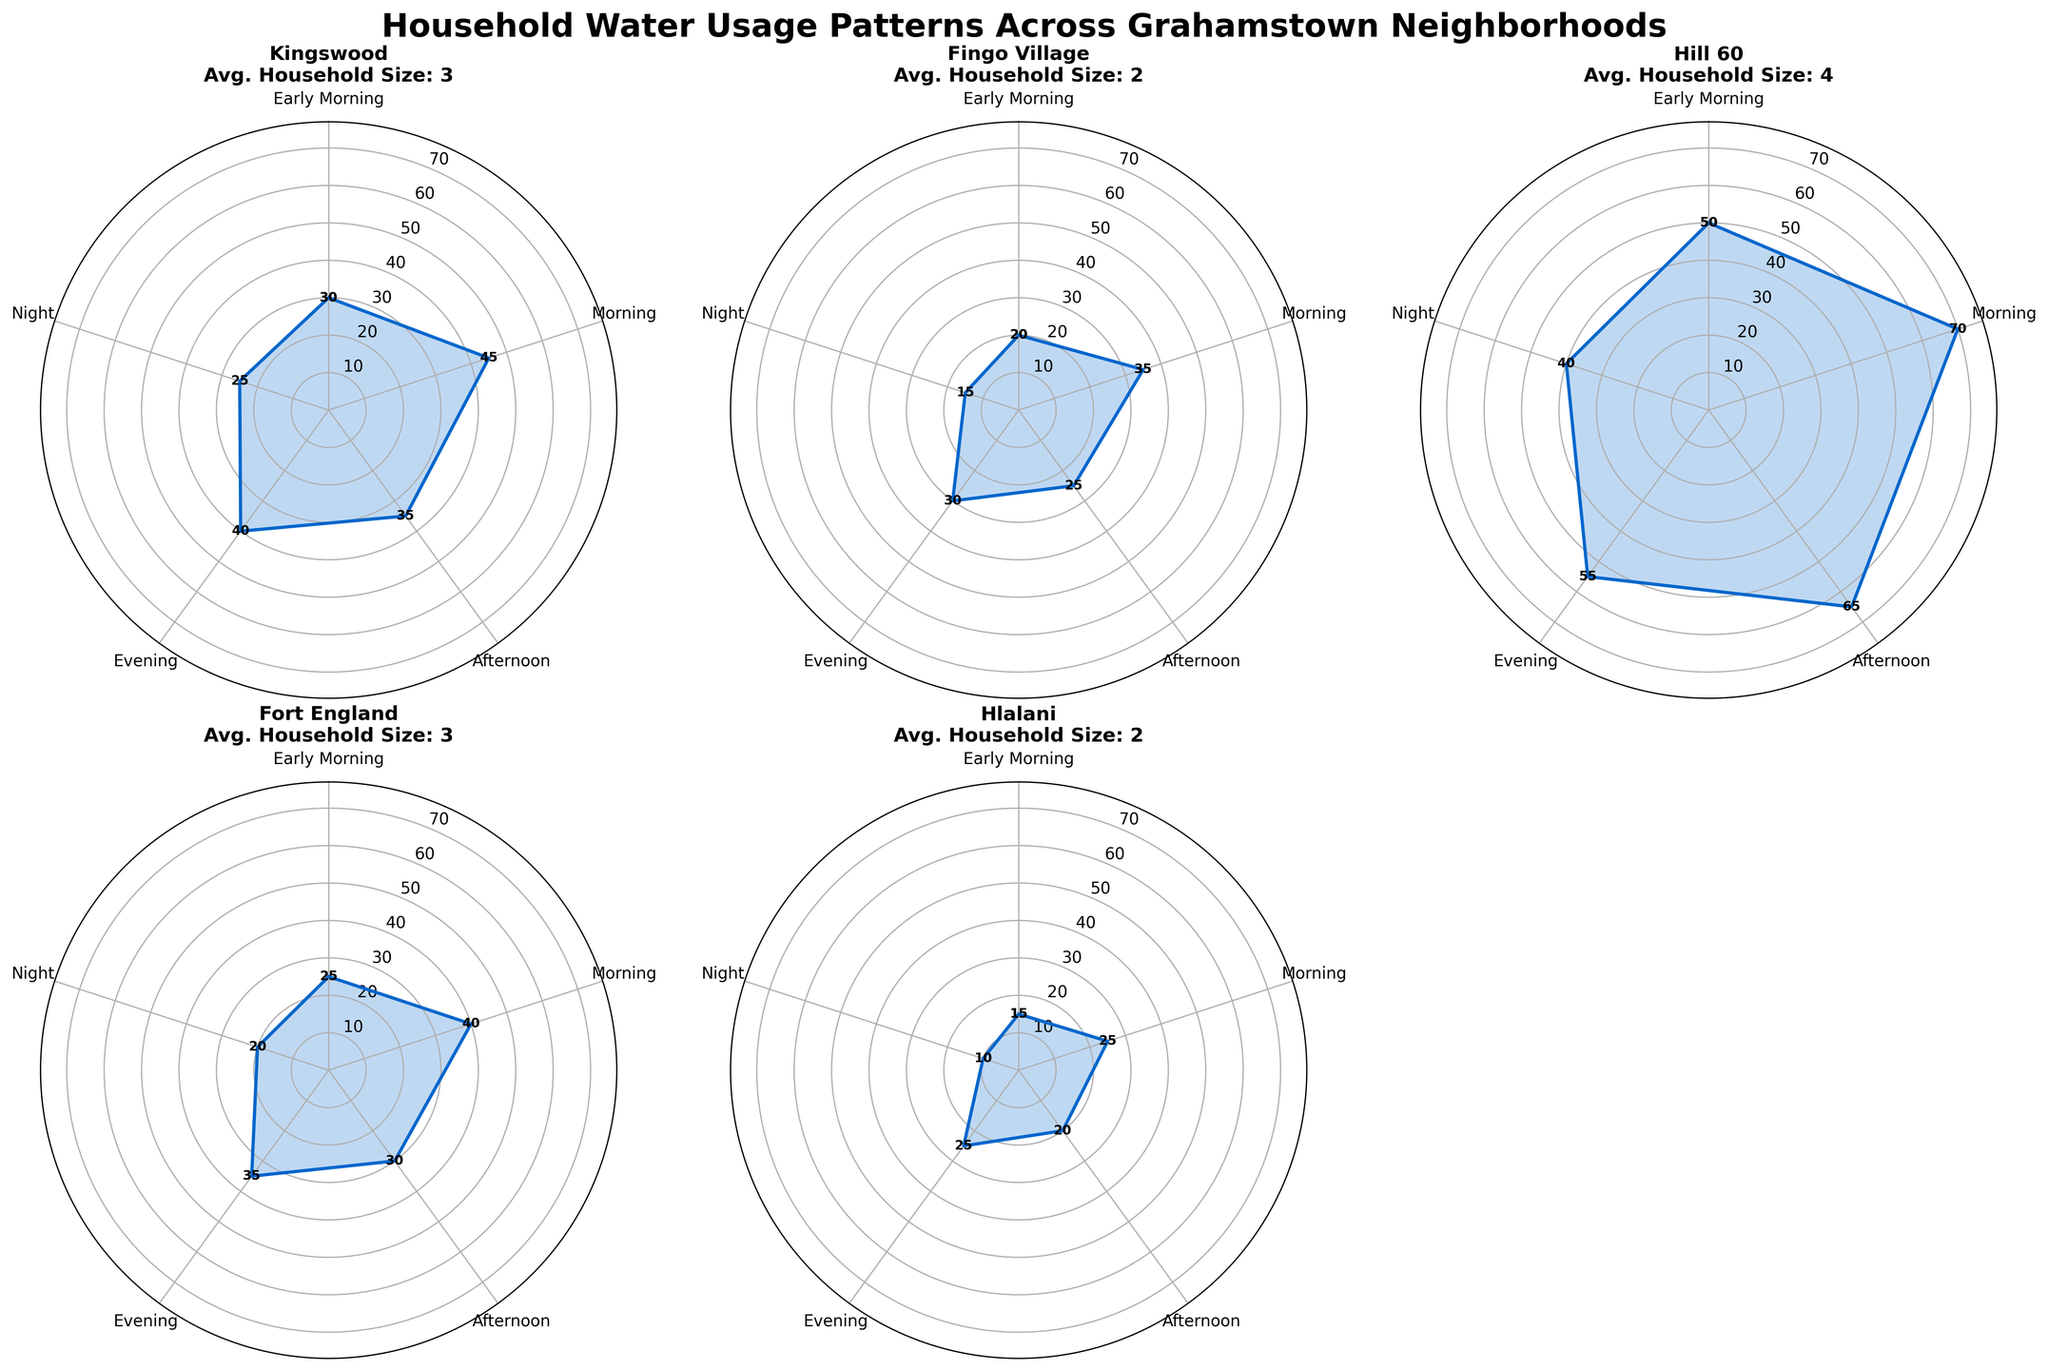Which neighborhood has the highest average household water usage in the Early Morning? By looking at the polar plots, the Early Morning usage can be visually assessed. Hill 60 shows the highest value at 50 liters compared to other neighborhoods that are generally lower.
Answer: Hill 60 In which neighborhood is the difference between Morning and Night water usage the largest? The difference between Morning and Night water usage for each neighborhood can be derived from the plots. Hill 60 has a Morning usage of 70 liters and a Night usage of 40 liters, a difference of 30 liters, which is larger than the other neighborhoods.
Answer: Hill 60 How does water usage in Kingswood change throughout the day? By analyzing the polar plot for Kingswood, the water usage starts at 30 liters (Early Morning), peaks at 45 liters (Morning), drops to 35 liters (Afternoon), again rises to 40 liters (Evening), and finally falls to 25 liters (Night).
Answer: Starts at 30 liters, peaks at 45 liters, drops to 35 liters, rises to 40 liters, falls to 25 liters Which neighborhood has the most consistent water usage throughout the day? Consistency can be judged by the least variance among the values on the plot. Fort England shows relatively consistent values ranging between 20 to 40 liters without large spikes or drops.
Answer: Fort England What is the average of the Evening water usage across all neighborhoods? Evening water usage values for each neighborhood are Kingswood (40), Fingo Village (30), Hill 60 (55), Fort England (35), Hlalani (25), and Oatlands North (50). Calculating the average: (40+30+55+35+25+50) / 6 = 235 / 6 ≈ 39.2.
Answer: 39.2 liters Which neighborhood's water usage peaks in the Afternoon? Examining the peak values on the polar plots, Hill 60 shows its highest value in the Afternoon with 65 liters, whereas other neighborhoods peak in different times of the day, such as Morning.
Answer: Hill 60 How does the water usage in Fingo Village at Night compare to Early Morning? By referencing the polar plot for Fingo Village, the Night usage is 15 liters and the Early Morning usage is 20 liters. Night usage is less than Early Morning.
Answer: Night usage is 5 liters less than Early Morning Which two neighborhoods have a similar pattern of water usage throughout the day? Patterns in water usage can be visually compared. Kingswood and Fort England show similar patterns with peaks in the Morning and declines by Night, though exact values differ.
Answer: Kingswood and Fort England What is the total water usage for Hlalani over the entire day? Summing the water usage for Hlalani from the polar plot: 15 (Early Morning) + 25 (Morning) + 20 (Afternoon) + 25 (Evening) + 10 (Night) = 95 liters.
Answer: 95 liters 